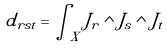Convert formula to latex. <formula><loc_0><loc_0><loc_500><loc_500>d _ { r s t } = \int _ { X } J _ { r } \wedge J _ { s } \wedge J _ { t }</formula> 